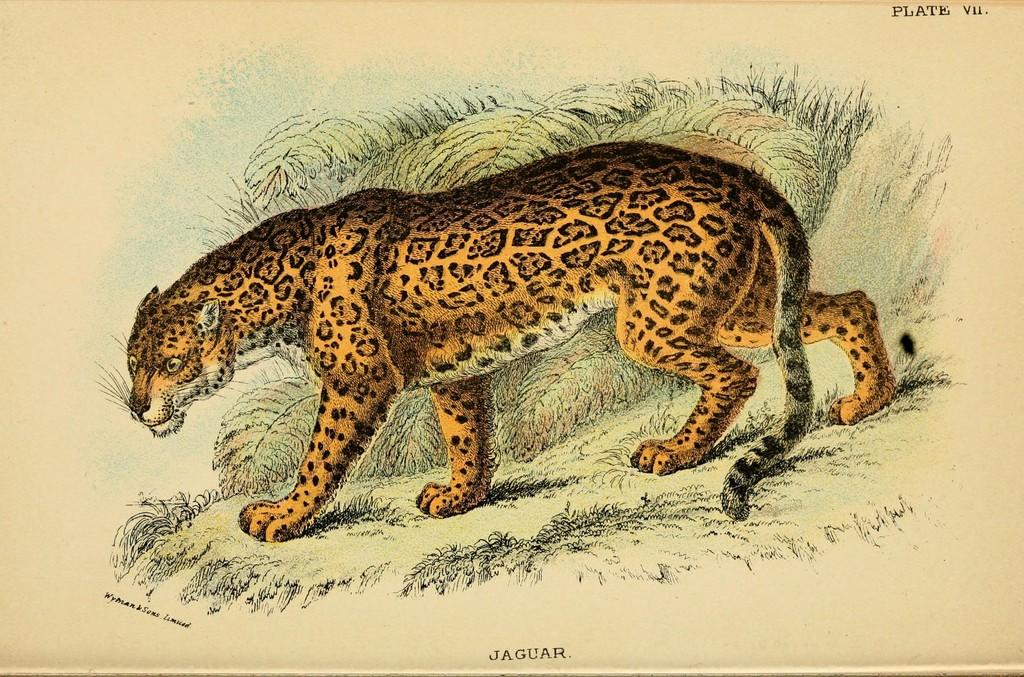What is present on the poster in the image? There is a poster in the image, and it features an animal. Can you describe the design on the poster? Yes, there is a design drawn on the poster. What else can be seen on the poster besides the design? There is text written on the poster. What type of pest can be seen crawling on the plate in the image? There is no plate or pest present in the image; it only features a poster with an animal, design, and text. 